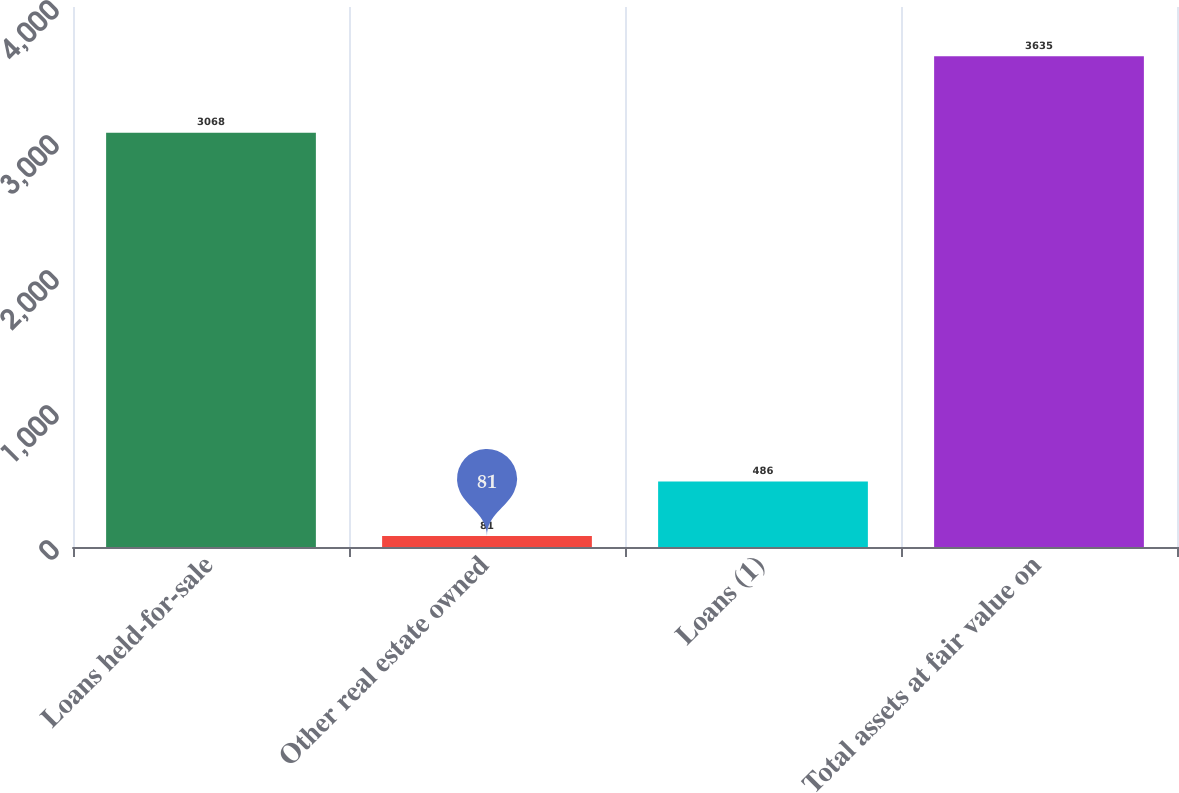Convert chart to OTSL. <chart><loc_0><loc_0><loc_500><loc_500><bar_chart><fcel>Loans held-for-sale<fcel>Other real estate owned<fcel>Loans (1)<fcel>Total assets at fair value on<nl><fcel>3068<fcel>81<fcel>486<fcel>3635<nl></chart> 